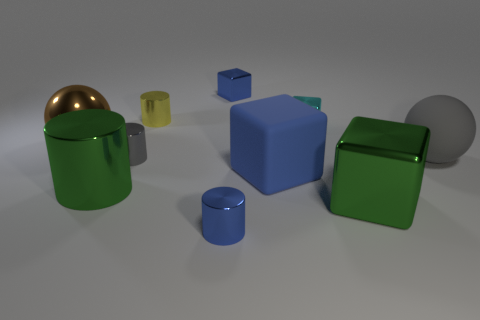Can you describe the objects and their colors in the picture? Certainly! In the image, there are several geometric shapes in various colors. Specifically, there's a large blue cube, a couple of green cylinders – one large and one small, two small blue cubes, a small yellow cylinder, one small gray sphere, and a large brown sphere with a metallic finish. 